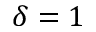<formula> <loc_0><loc_0><loc_500><loc_500>\delta = 1</formula> 